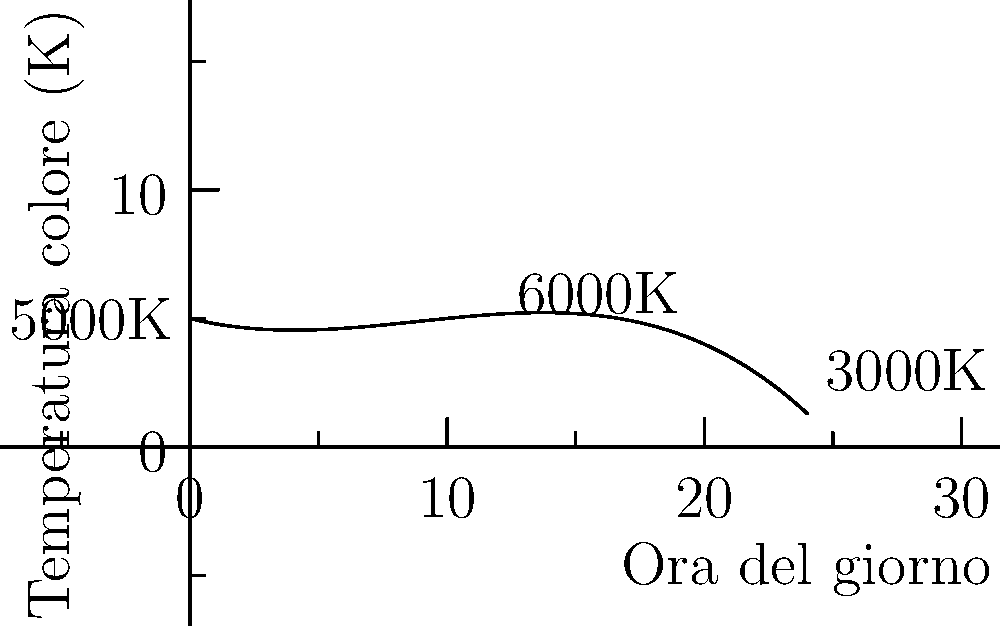Analizzando il grafico che rappresenta la variazione della temperatura colore durante il giorno, quale grado di funzione polinomiale descrive meglio questa curva? Spiega brevemente come hai determinato la risposta. Per determinare il grado del polinomio, seguiamo questi passaggi:

1. Osserviamo la forma della curva: non è una linea retta, quindi non è di primo grado.

2. La curva ha più di un cambio di direzione (concavità), quindi non può essere di secondo grado, che avrebbe una sola parabola.

3. Notiamo che la curva ha due punti di flesso, dove cambia la sua concavità. Questo è tipico di una funzione polinomiale di terzo grado.

4. La curva inizia salendo, poi scende, e infine risale leggermente verso la fine. Questo comportamento è coerente con un polinomio di terzo grado.

5. Non ci sono oscillazioni aggiuntive o complessità che suggerirebbero un grado superiore al terzo.

Quindi, basandoci sulla forma della curva e sul numero di cambiamenti di concavità, possiamo concludere che la funzione che meglio descrive questa variazione di temperatura colore è un polinomio di terzo grado.
Answer: Polinomio di terzo grado 